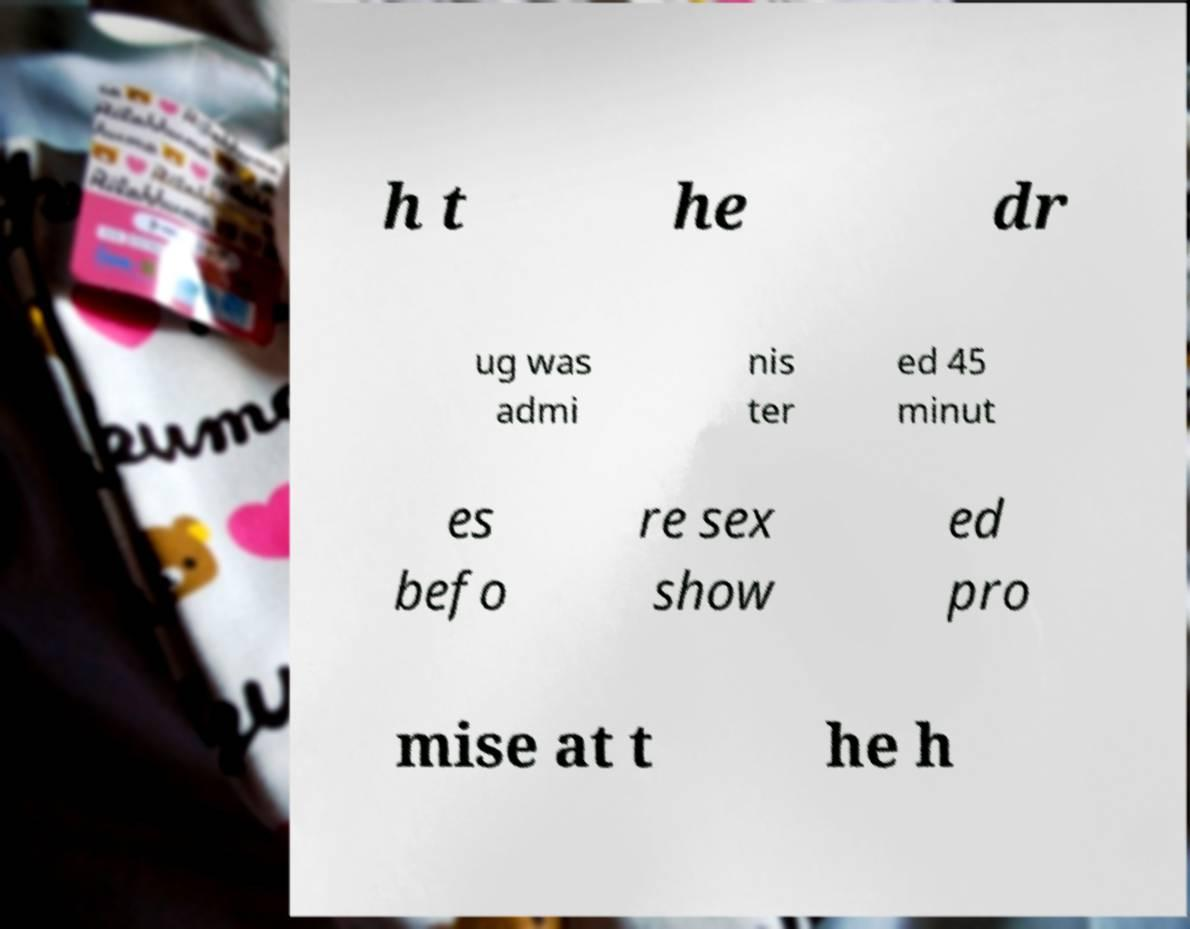I need the written content from this picture converted into text. Can you do that? h t he dr ug was admi nis ter ed 45 minut es befo re sex show ed pro mise at t he h 